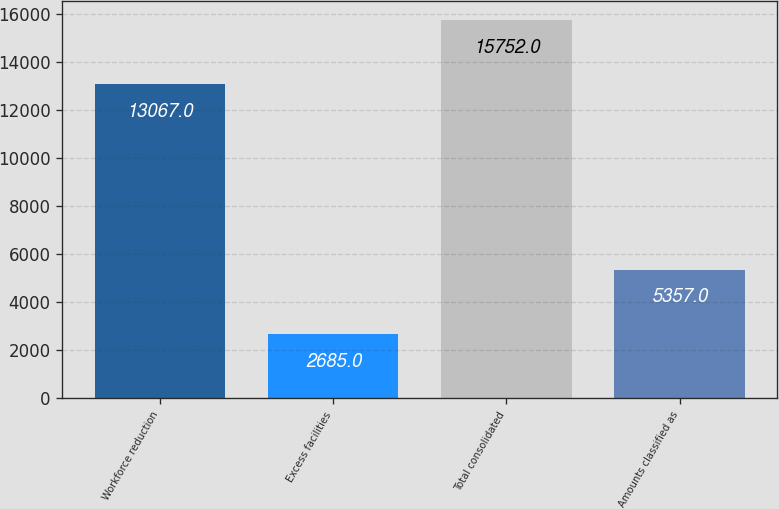<chart> <loc_0><loc_0><loc_500><loc_500><bar_chart><fcel>Workforce reduction<fcel>Excess facilities<fcel>Total consolidated<fcel>Amounts classified as<nl><fcel>13067<fcel>2685<fcel>15752<fcel>5357<nl></chart> 